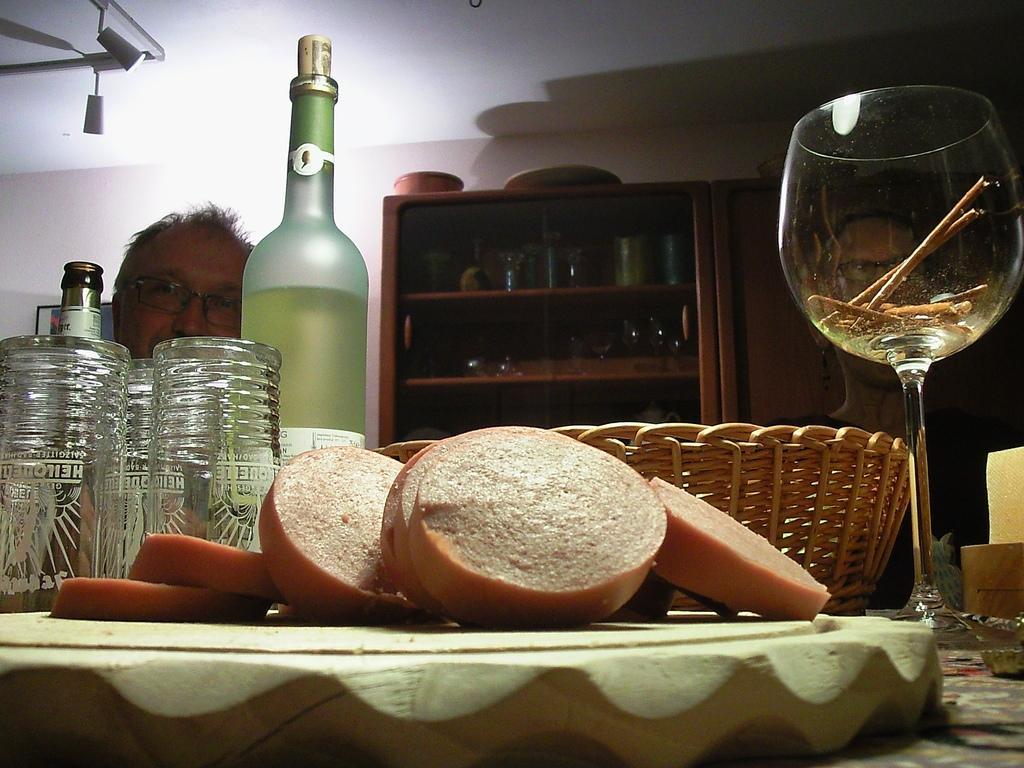Describe this image in one or two sentences. This picture is consists of bottles and glasses and a set of utensils at the right side of the image and there is a man who is sitting at the left side of the image. 